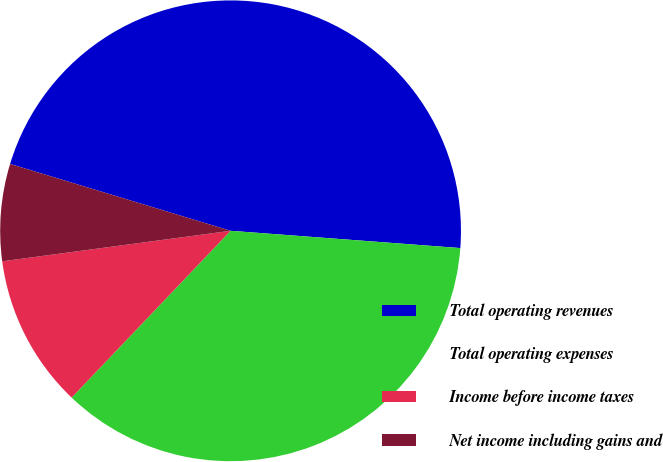Convert chart to OTSL. <chart><loc_0><loc_0><loc_500><loc_500><pie_chart><fcel>Total operating revenues<fcel>Total operating expenses<fcel>Income before income taxes<fcel>Net income including gains and<nl><fcel>46.51%<fcel>35.92%<fcel>10.77%<fcel>6.8%<nl></chart> 